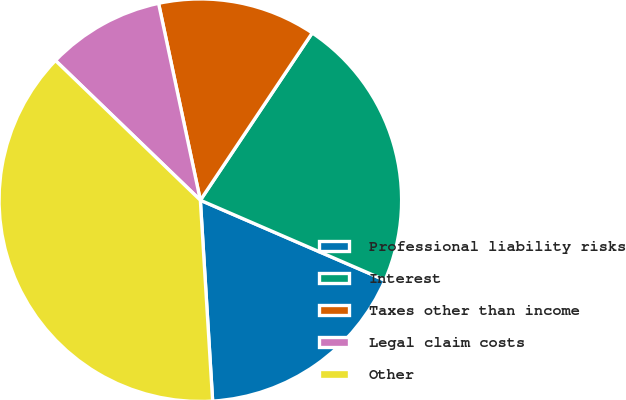Convert chart. <chart><loc_0><loc_0><loc_500><loc_500><pie_chart><fcel>Professional liability risks<fcel>Interest<fcel>Taxes other than income<fcel>Legal claim costs<fcel>Other<nl><fcel>17.52%<fcel>22.12%<fcel>12.71%<fcel>9.46%<fcel>38.18%<nl></chart> 